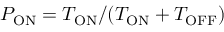<formula> <loc_0><loc_0><loc_500><loc_500>P _ { O N } = T _ { O N } / ( T _ { O N } + T _ { O F F } )</formula> 